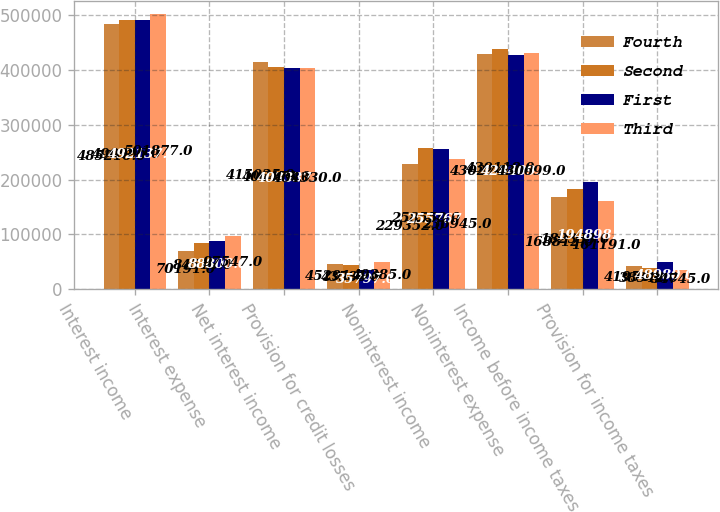<chart> <loc_0><loc_0><loc_500><loc_500><stacked_bar_chart><ecel><fcel>Interest income<fcel>Interest expense<fcel>Net interest income<fcel>Provision for credit losses<fcel>Noninterest income<fcel>Noninterest expense<fcel>Income before income taxes<fcel>Provision for income taxes<nl><fcel>Fourth<fcel>485216<fcel>70191<fcel>415025<fcel>45291<fcel>229352<fcel>430274<fcel>168812<fcel>41954<nl><fcel>Second<fcel>490996<fcel>84518<fcel>406478<fcel>43586<fcel>258559<fcel>439118<fcel>182333<fcel>38942<nl><fcel>First<fcel>492137<fcel>88800<fcel>403337<fcel>35797<fcel>255767<fcel>428409<fcel>194898<fcel>48980<nl><fcel>Third<fcel>501877<fcel>97547<fcel>404330<fcel>49385<fcel>236945<fcel>430699<fcel>161191<fcel>34745<nl></chart> 